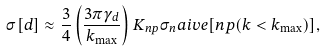Convert formula to latex. <formula><loc_0><loc_0><loc_500><loc_500>\sigma [ d ] \approx \frac { 3 } { 4 } \left ( \frac { 3 \pi \gamma _ { d } } { k _ { \max } } \right ) K _ { n p } \sigma _ { n } a i v e [ n p ( k < k _ { \max } ) ] ,</formula> 